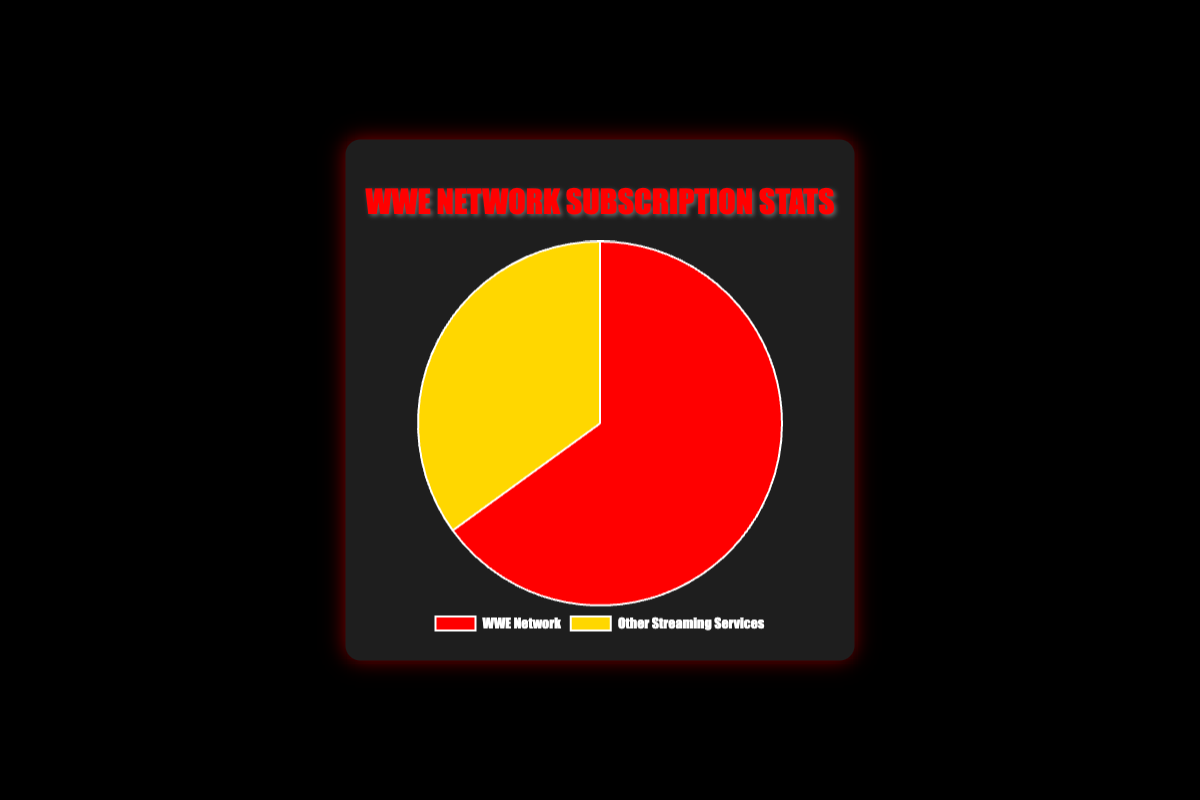What percentage of US-based WWE fans are subscribed to WWE Network? The chart shows a pie chart with two segments, one for WWE Network and one for Other Streaming Services. The segment for WWE Network shows a percentage of 65%.
Answer: 65% What percentage of US-based WWE fans are subscribed to other streaming services? The chart indicates two percentages, one for WWE Network and one for Other Streaming Services. The segment for Other Streaming Services shows a percentage of 35%.
Answer: 35% Which service has a higher percentage of US-based WWE fans: WWE Network or Other Streaming Services? The pie chart displays percentages for two categories. WWE Network has a larger segment showing 65%, compared to Other Streaming Services at 35%.
Answer: WWE Network What is the difference in percentage between WWE Network subscribers and subscribers of other streaming services? From the chart, WWE Network has 65% while Other Streaming Services has 35%. The difference is calculated as 65% - 35%.
Answer: 30% What two colors are used to represent WWE Network and Other Streaming Services on the pie chart? The chart legend shows WWE Network in red and Other Streaming Services in yellow.
Answer: Red and Yellow By what factor is the percentage of WWE Network subscribers larger than that of other streaming services? To find the factor, divide the percentage of WWE Network subscribers by the percentage of other streaming services: 65% / 35%.
Answer: 1.857 (approximately 1.86) If we combined the percentages of both categories, what is the total percentage represented in the chart? Adding the two percentages together, WWE Network (65%) and Other Streaming Services (35%), gives a total of 65% + 35%.
Answer: 100% If 1,000 US-based WWE fans were surveyed, approximately how many of them are subscribed to WWE Network? Using the percentage from the chart (65%) and applying it to 1,000 fans: 0.65 * 1,000.
Answer: 650 